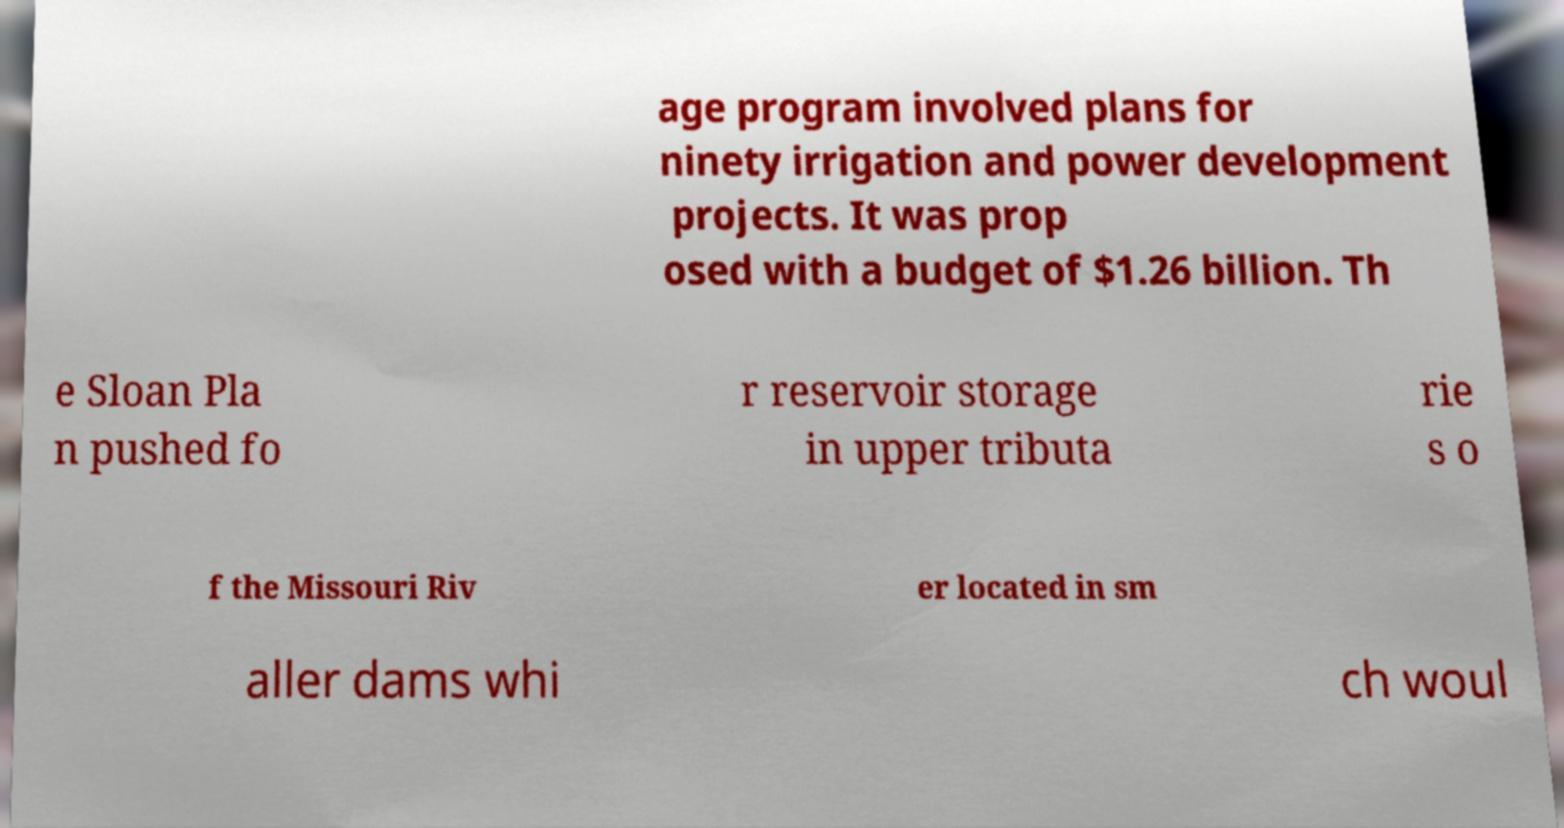Could you assist in decoding the text presented in this image and type it out clearly? age program involved plans for ninety irrigation and power development projects. It was prop osed with a budget of $1.26 billion. Th e Sloan Pla n pushed fo r reservoir storage in upper tributa rie s o f the Missouri Riv er located in sm aller dams whi ch woul 